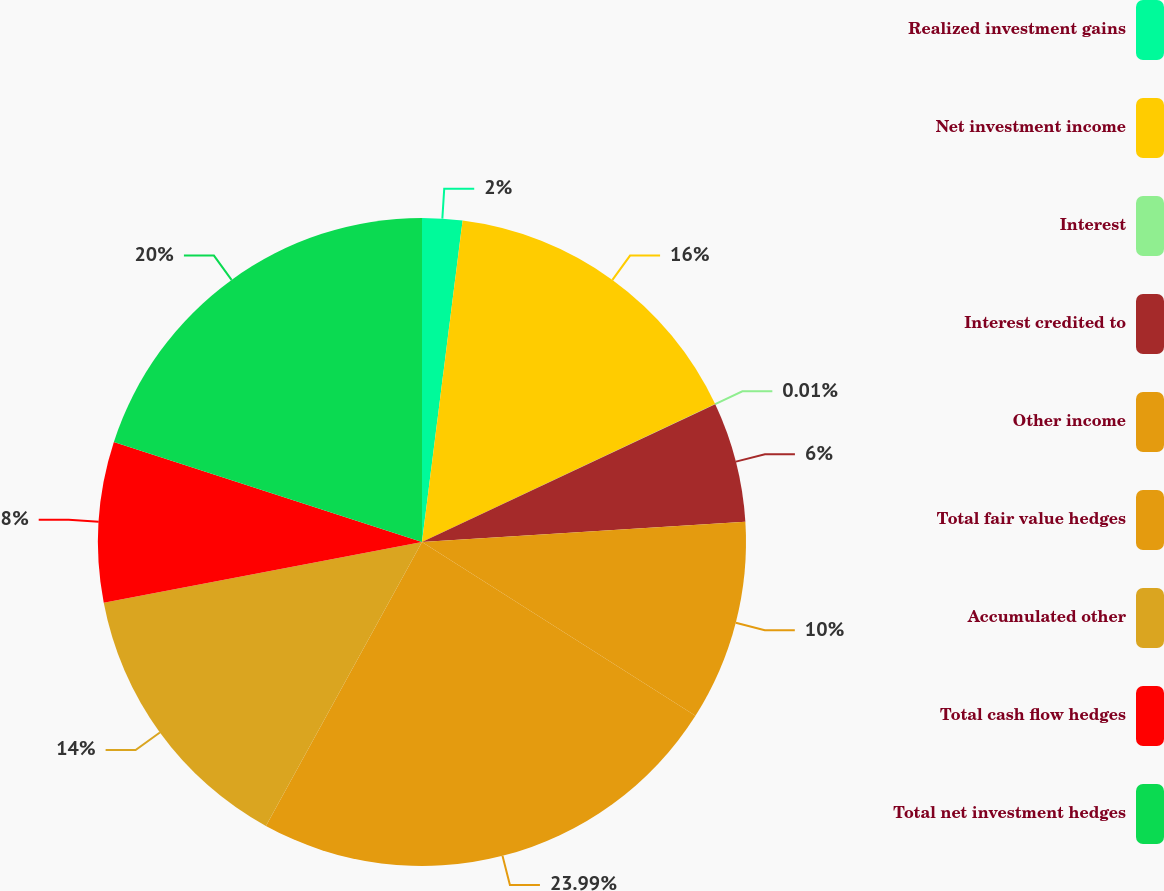Convert chart to OTSL. <chart><loc_0><loc_0><loc_500><loc_500><pie_chart><fcel>Realized investment gains<fcel>Net investment income<fcel>Interest<fcel>Interest credited to<fcel>Other income<fcel>Total fair value hedges<fcel>Accumulated other<fcel>Total cash flow hedges<fcel>Total net investment hedges<nl><fcel>2.0%<fcel>16.0%<fcel>0.01%<fcel>6.0%<fcel>10.0%<fcel>23.99%<fcel>14.0%<fcel>8.0%<fcel>20.0%<nl></chart> 